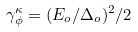<formula> <loc_0><loc_0><loc_500><loc_500>\gamma _ { \phi } ^ { \kappa } = ( E _ { o } / \Delta _ { o } ) ^ { 2 } / 2</formula> 